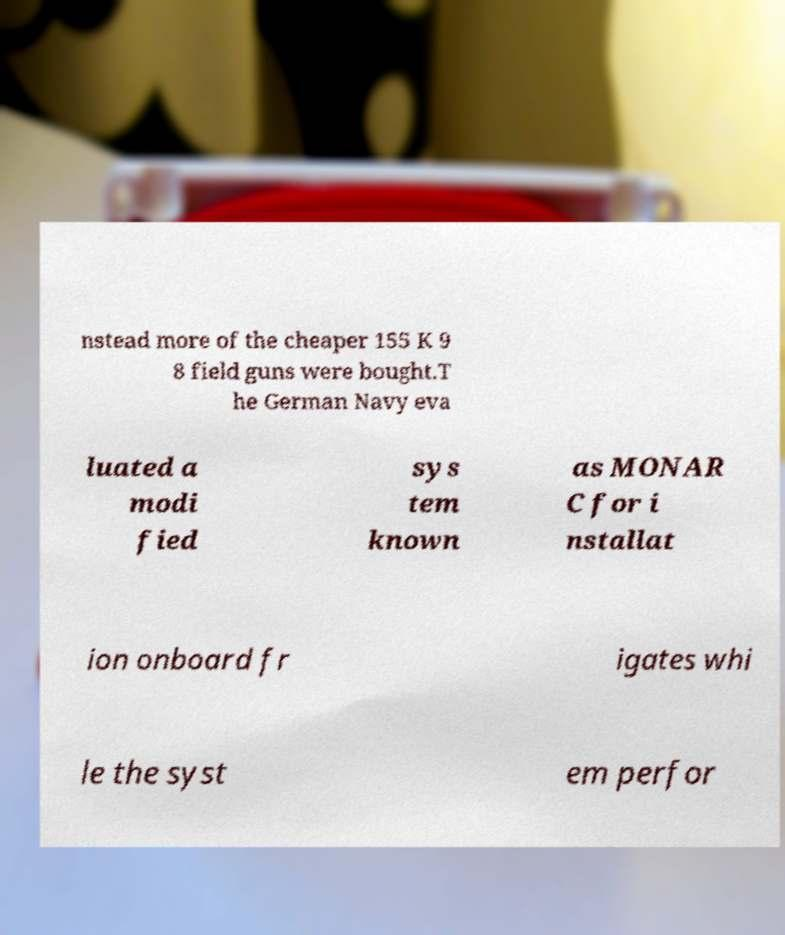Could you extract and type out the text from this image? nstead more of the cheaper 155 K 9 8 field guns were bought.T he German Navy eva luated a modi fied sys tem known as MONAR C for i nstallat ion onboard fr igates whi le the syst em perfor 